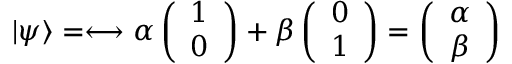Convert formula to latex. <formula><loc_0><loc_0><loc_500><loc_500>| \psi \rangle = \longleftrightarrow \alpha \left ( \begin{array} { l } { 1 } \\ { 0 } \end{array} \right ) + \beta \left ( \begin{array} { l } { 0 } \\ { 1 } \end{array} \right ) = \left ( \begin{array} { l } { \alpha } \\ { \beta } \end{array} \right )</formula> 